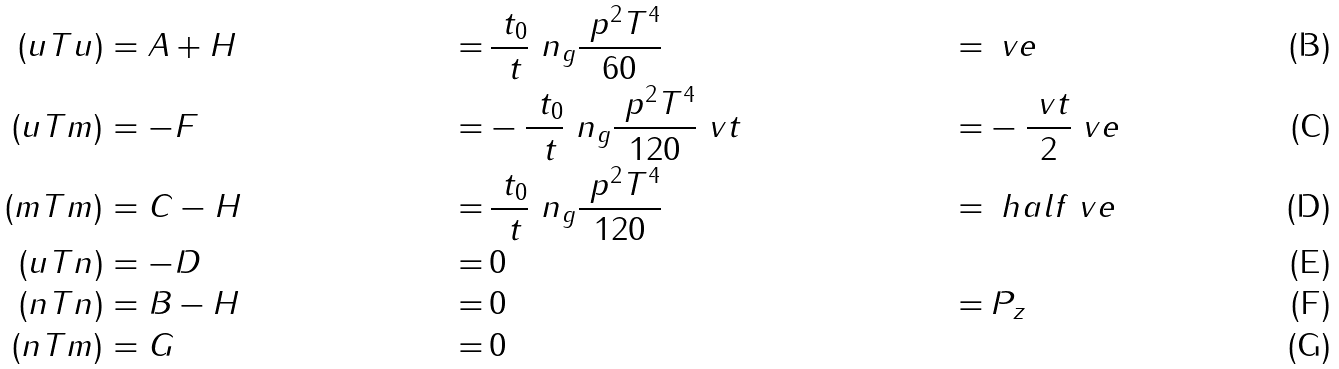<formula> <loc_0><loc_0><loc_500><loc_500>( u T u ) & = A + H \, & = & \, \frac { \ t _ { 0 } } { \ t } \ n _ { g } \frac { \ p ^ { 2 } T ^ { 4 } } { 6 0 } \, & = & \, \ v e \\ ( u T m ) & = - F \, & = & - \frac { \ t _ { 0 } } { \ t } \ n _ { g } \frac { \ p ^ { 2 } T ^ { 4 } } { 1 2 0 } \ v t \, & = & - \frac { \ v t } { 2 } \ v e \\ ( m T m ) & = C - H \, & = & \, \frac { \ t _ { 0 } } { \ t } \ n _ { g } \frac { \ p ^ { 2 } T ^ { 4 } } { 1 2 0 } & = & \, \ h a l f \ v e \\ ( u T n ) & = - D & = & \, 0 & & \, \\ ( n T n ) & = B - H \, & = & \, 0 & = & \, P _ { z } \\ ( n T m ) & = G & = & \, 0</formula> 